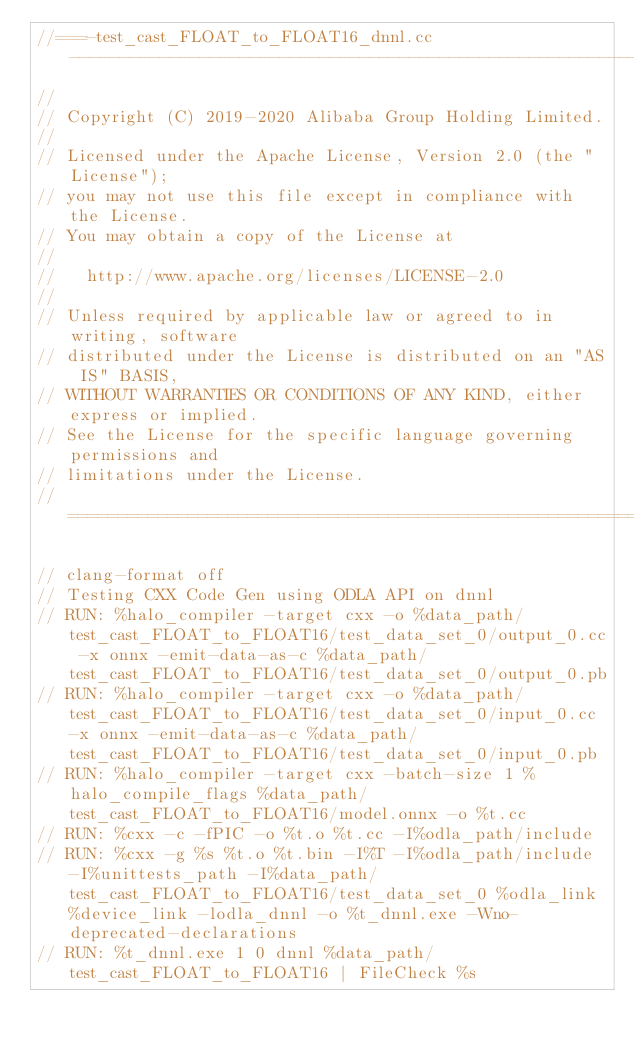<code> <loc_0><loc_0><loc_500><loc_500><_C++_>//===-test_cast_FLOAT_to_FLOAT16_dnnl.cc-----------------------------------------------------------===//
//
// Copyright (C) 2019-2020 Alibaba Group Holding Limited.
//
// Licensed under the Apache License, Version 2.0 (the "License");
// you may not use this file except in compliance with the License.
// You may obtain a copy of the License at
//
//   http://www.apache.org/licenses/LICENSE-2.0
//
// Unless required by applicable law or agreed to in writing, software
// distributed under the License is distributed on an "AS IS" BASIS,
// WITHOUT WARRANTIES OR CONDITIONS OF ANY KIND, either express or implied.
// See the License for the specific language governing permissions and
// limitations under the License.
// =============================================================================

// clang-format off
// Testing CXX Code Gen using ODLA API on dnnl
// RUN: %halo_compiler -target cxx -o %data_path/test_cast_FLOAT_to_FLOAT16/test_data_set_0/output_0.cc -x onnx -emit-data-as-c %data_path/test_cast_FLOAT_to_FLOAT16/test_data_set_0/output_0.pb
// RUN: %halo_compiler -target cxx -o %data_path/test_cast_FLOAT_to_FLOAT16/test_data_set_0/input_0.cc -x onnx -emit-data-as-c %data_path/test_cast_FLOAT_to_FLOAT16/test_data_set_0/input_0.pb
// RUN: %halo_compiler -target cxx -batch-size 1 %halo_compile_flags %data_path/test_cast_FLOAT_to_FLOAT16/model.onnx -o %t.cc
// RUN: %cxx -c -fPIC -o %t.o %t.cc -I%odla_path/include
// RUN: %cxx -g %s %t.o %t.bin -I%T -I%odla_path/include -I%unittests_path -I%data_path/test_cast_FLOAT_to_FLOAT16/test_data_set_0 %odla_link %device_link -lodla_dnnl -o %t_dnnl.exe -Wno-deprecated-declarations
// RUN: %t_dnnl.exe 1 0 dnnl %data_path/test_cast_FLOAT_to_FLOAT16 | FileCheck %s</code> 